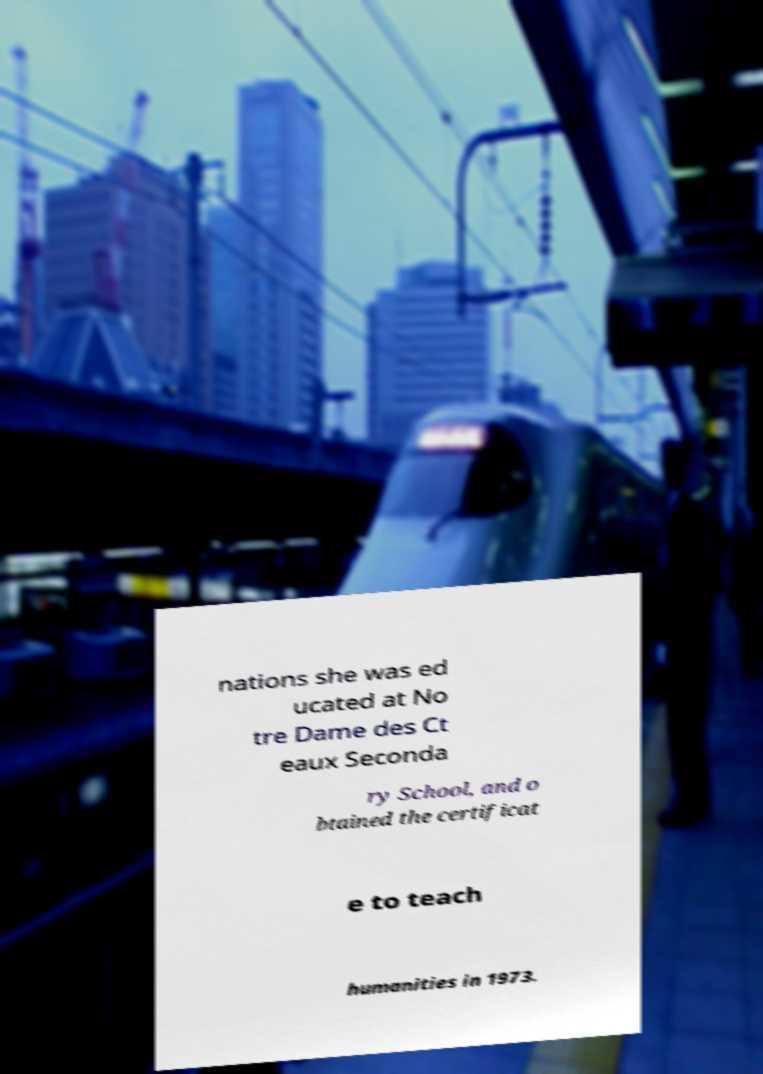I need the written content from this picture converted into text. Can you do that? nations she was ed ucated at No tre Dame des Ct eaux Seconda ry School, and o btained the certificat e to teach humanities in 1973. 